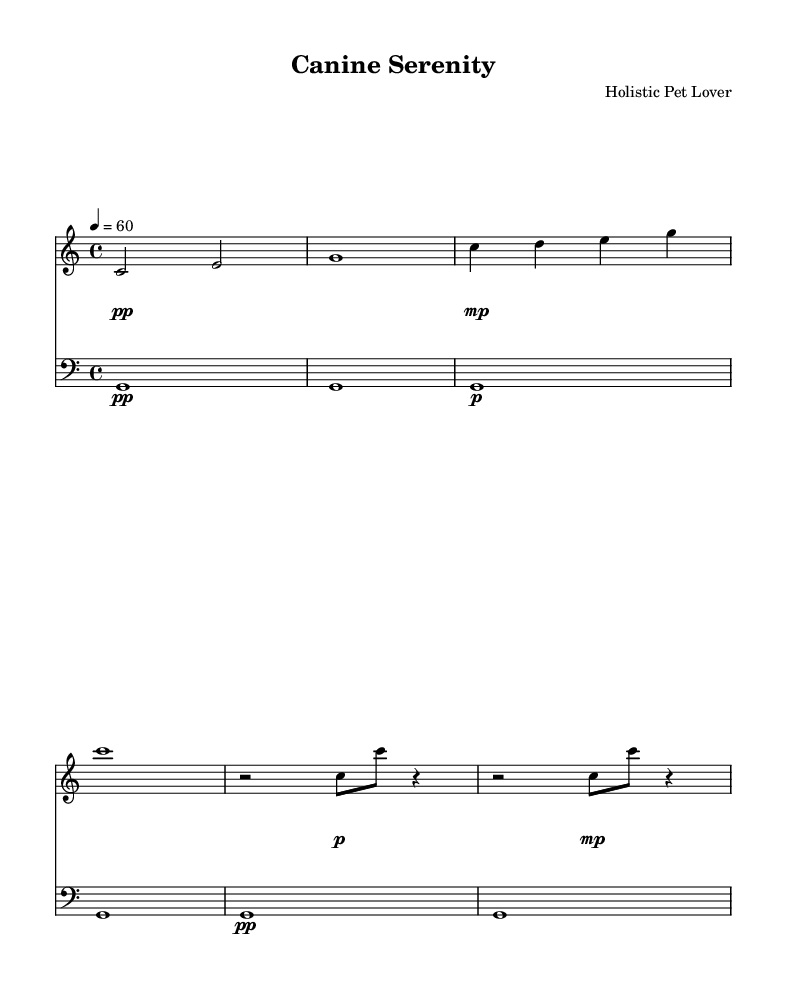What is the key signature of this music? The key signature is C major, which has no sharps or flats.
Answer: C major What is the time signature of the piece? The time signature is indicated at the beginning of the score, which shows that there are 4 beats in each measure.
Answer: 4/4 What is the tempo marking of the music? The tempo marking shows a tempo of 60 beats per minute, indicated by "4 = 60" where the 4 denotes a quarter note beat.
Answer: 60 How many measures are in the section A of the piece? In section A, there are 6 measures based on the grouping and layout of the notes presented.
Answer: 6 What dynamics are indicated for the piano in the introduction? The dynamics indicated for the piano during the introduction show a soft dynamic (piano), gradually getting louder (crescendo) and returning to a soft level.
Answer: pianissimo to piano What is the significance of the breathing pattern in the cello part? The breathing pattern in the cello part is represented by sustained notes, mimicking the natural rhythm of a dog's breathing, highlighting the holistic theme of the piece.
Answer: Mimics dog's breathing What unique musical aspect does this piece embody compared to traditional compositions? This piece embodies a minimalist approach, focusing on simple repetitive patterns that evoke feelings of calmness in relation to the rhythmic patterns of canine life.
Answer: Minimalist composition 